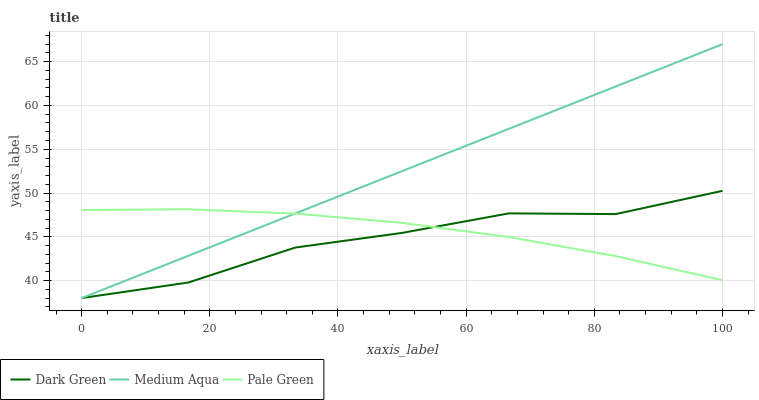Does Dark Green have the minimum area under the curve?
Answer yes or no. Yes. Does Medium Aqua have the maximum area under the curve?
Answer yes or no. Yes. Does Medium Aqua have the minimum area under the curve?
Answer yes or no. No. Does Dark Green have the maximum area under the curve?
Answer yes or no. No. Is Medium Aqua the smoothest?
Answer yes or no. Yes. Is Dark Green the roughest?
Answer yes or no. Yes. Is Dark Green the smoothest?
Answer yes or no. No. Is Medium Aqua the roughest?
Answer yes or no. No. Does Medium Aqua have the lowest value?
Answer yes or no. Yes. Does Medium Aqua have the highest value?
Answer yes or no. Yes. Does Dark Green have the highest value?
Answer yes or no. No. Does Pale Green intersect Medium Aqua?
Answer yes or no. Yes. Is Pale Green less than Medium Aqua?
Answer yes or no. No. Is Pale Green greater than Medium Aqua?
Answer yes or no. No. 